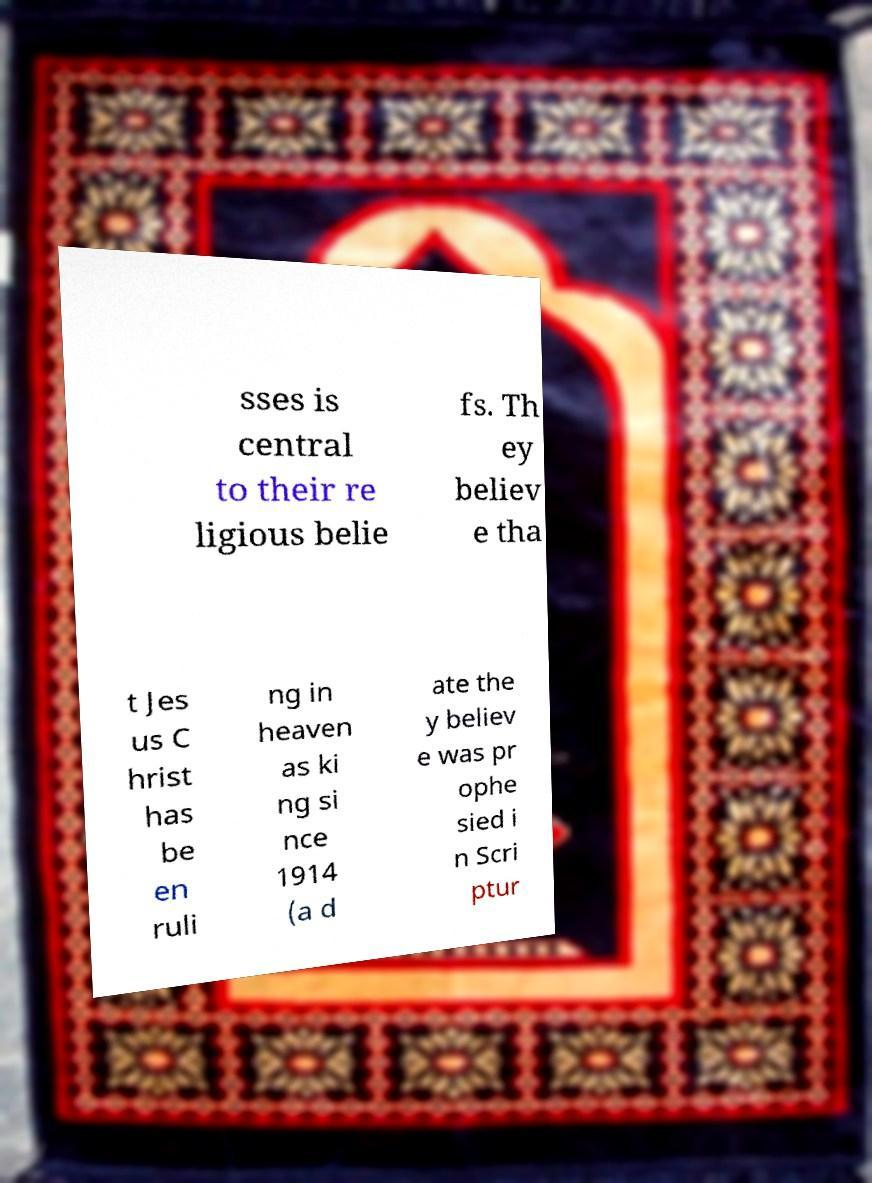Could you extract and type out the text from this image? sses is central to their re ligious belie fs. Th ey believ e tha t Jes us C hrist has be en ruli ng in heaven as ki ng si nce 1914 (a d ate the y believ e was pr ophe sied i n Scri ptur 